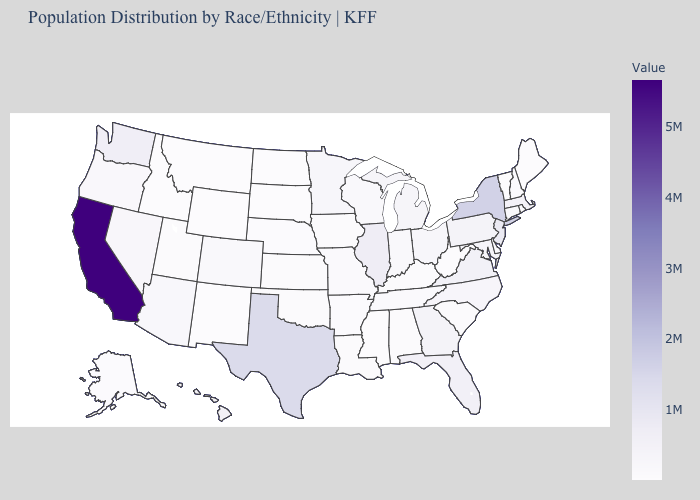Among the states that border Colorado , which have the lowest value?
Give a very brief answer. Wyoming. Does the map have missing data?
Short answer required. No. Does Minnesota have a lower value than New York?
Give a very brief answer. Yes. Which states have the highest value in the USA?
Quick response, please. California. 